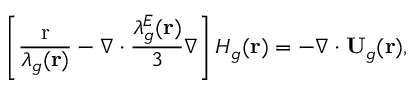Convert formula to latex. <formula><loc_0><loc_0><loc_500><loc_500>\left [ { \frac { r } { { { \lambda _ { g } } ( { r } ) } } - \nabla \cdot \frac { { \lambda _ { g } ^ { E } ( { r } ) } } { 3 } \nabla } \right ] { H _ { g } } ( { r } ) = - \nabla \cdot { { U } _ { g } } ( { r } ) ,</formula> 